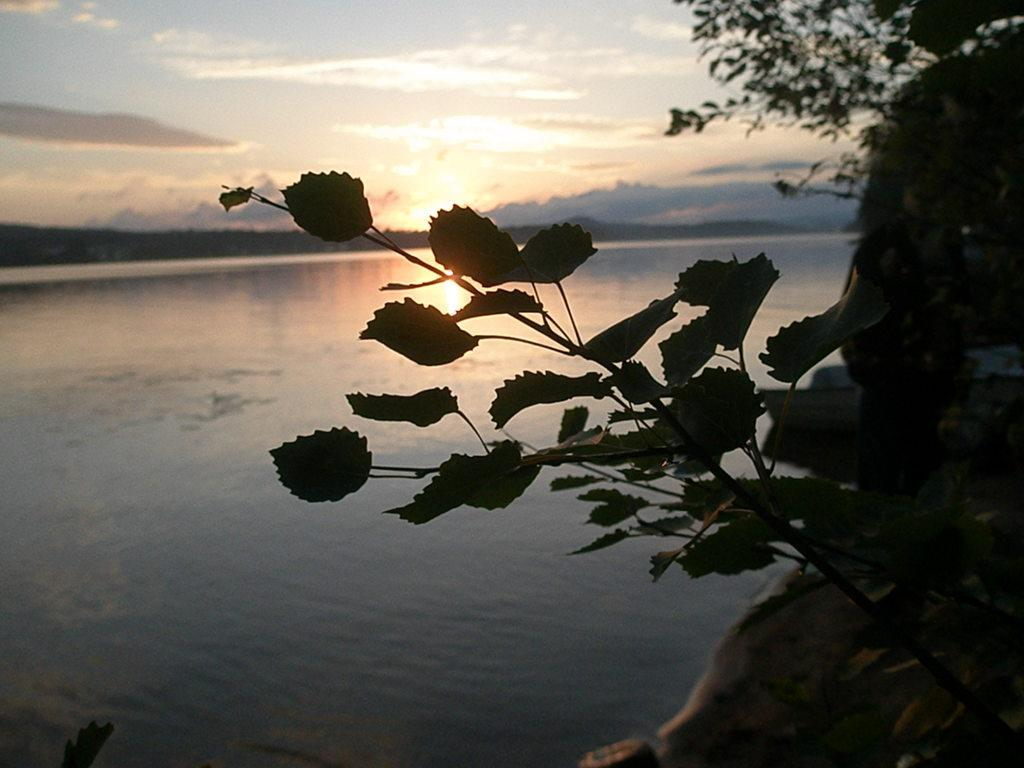What type of vegetation can be seen in the image? There are plants and trees in the image. What natural feature is present in the image? There is a river in the image. What can be seen in the background of the image? The sky is visible in the background of the image. What type of meat is being cooked in the river in the image? There is no meat or cooking activity present in the image; it features plants, trees, a river, and the sky. 